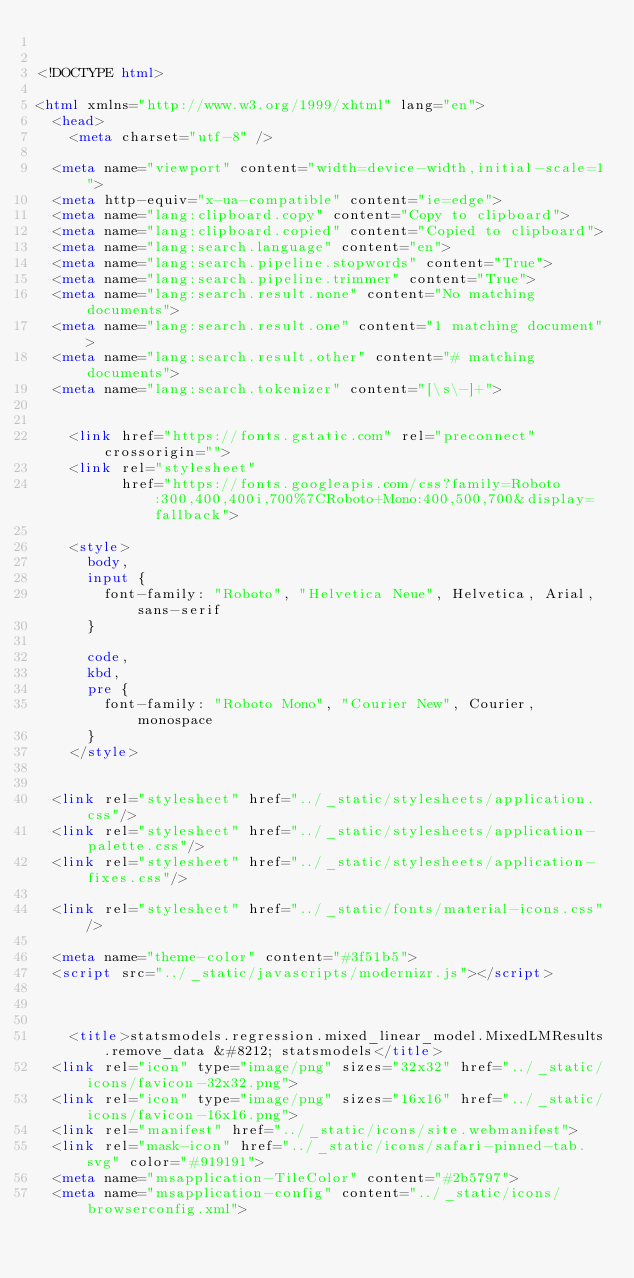<code> <loc_0><loc_0><loc_500><loc_500><_HTML_>

<!DOCTYPE html>

<html xmlns="http://www.w3.org/1999/xhtml" lang="en">
  <head>
    <meta charset="utf-8" />
  
  <meta name="viewport" content="width=device-width,initial-scale=1">
  <meta http-equiv="x-ua-compatible" content="ie=edge">
  <meta name="lang:clipboard.copy" content="Copy to clipboard">
  <meta name="lang:clipboard.copied" content="Copied to clipboard">
  <meta name="lang:search.language" content="en">
  <meta name="lang:search.pipeline.stopwords" content="True">
  <meta name="lang:search.pipeline.trimmer" content="True">
  <meta name="lang:search.result.none" content="No matching documents">
  <meta name="lang:search.result.one" content="1 matching document">
  <meta name="lang:search.result.other" content="# matching documents">
  <meta name="lang:search.tokenizer" content="[\s\-]+">

  
    <link href="https://fonts.gstatic.com" rel="preconnect" crossorigin="">
    <link rel="stylesheet"
          href="https://fonts.googleapis.com/css?family=Roboto:300,400,400i,700%7CRoboto+Mono:400,500,700&display=fallback">

    <style>
      body,
      input {
        font-family: "Roboto", "Helvetica Neue", Helvetica, Arial, sans-serif
      }

      code,
      kbd,
      pre {
        font-family: "Roboto Mono", "Courier New", Courier, monospace
      }
    </style>
  

  <link rel="stylesheet" href="../_static/stylesheets/application.css"/>
  <link rel="stylesheet" href="../_static/stylesheets/application-palette.css"/>
  <link rel="stylesheet" href="../_static/stylesheets/application-fixes.css"/>
  
  <link rel="stylesheet" href="../_static/fonts/material-icons.css"/>
  
  <meta name="theme-color" content="#3f51b5">
  <script src="../_static/javascripts/modernizr.js"></script>
  
  
  
    <title>statsmodels.regression.mixed_linear_model.MixedLMResults.remove_data &#8212; statsmodels</title>
  <link rel="icon" type="image/png" sizes="32x32" href="../_static/icons/favicon-32x32.png">
  <link rel="icon" type="image/png" sizes="16x16" href="../_static/icons/favicon-16x16.png">
  <link rel="manifest" href="../_static/icons/site.webmanifest">
  <link rel="mask-icon" href="../_static/icons/safari-pinned-tab.svg" color="#919191">
  <meta name="msapplication-TileColor" content="#2b5797">
  <meta name="msapplication-config" content="../_static/icons/browserconfig.xml"></code> 